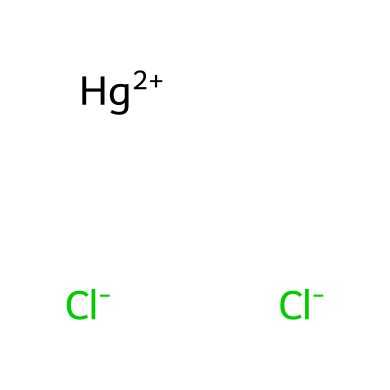What is the molecular formula of mercuric chloride? The molecular formula can be deduced from the given SMILES: there are two chlorine atoms and one mercury atom, which combines to give the formula HgCl2.
Answer: HgCl2 How many chlorine atoms are present in the structure? By analyzing the SMILES representation, there are two instances of chlorine ([Cl-]), hence there are two chlorine atoms in mercuric chloride.
Answer: 2 What is the oxidation state of mercury in this compound? In the structure of mercuric chloride, mercury is represented as Hg+2, indicating that mercury has an oxidation state of +2.
Answer: +2 Is mercuric chloride an oxidizing agent? Mercuric chloride typically acts as an oxidizing agent due to its ability to accept electrons, consistent with the characteristics of such compounds in chemical reactions.
Answer: Yes What type of bonding exists between mercury and chlorine in mercuric chloride? The bonding in this compound involves ionic bonds, where the mercury ion (Hg+2) interacts with the chloride ions (Cl-), creating a stable structure through electrostatic attraction.
Answer: Ionic bonds Can this compound be classified as a heavy metal salt? The presence of mercury, which is considered a heavy metal, alongside chloride ions indicates that mercuric chloride can be classified as a heavy metal salt.
Answer: Yes What are the main historical uses of mercuric chloride in the 18th century? During the 18th century, mercuric chloride was primarily used in medicine for its antiseptic properties and occasionally as a poison or weapon due to its toxicity.
Answer: Antiseptic, poison 